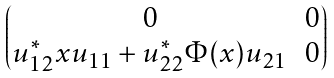<formula> <loc_0><loc_0><loc_500><loc_500>\begin{pmatrix} 0 & 0 \\ u _ { 1 2 } ^ { * } x u _ { 1 1 } + u _ { 2 2 } ^ { * } \Phi ( x ) u _ { 2 1 } & 0 \end{pmatrix}</formula> 